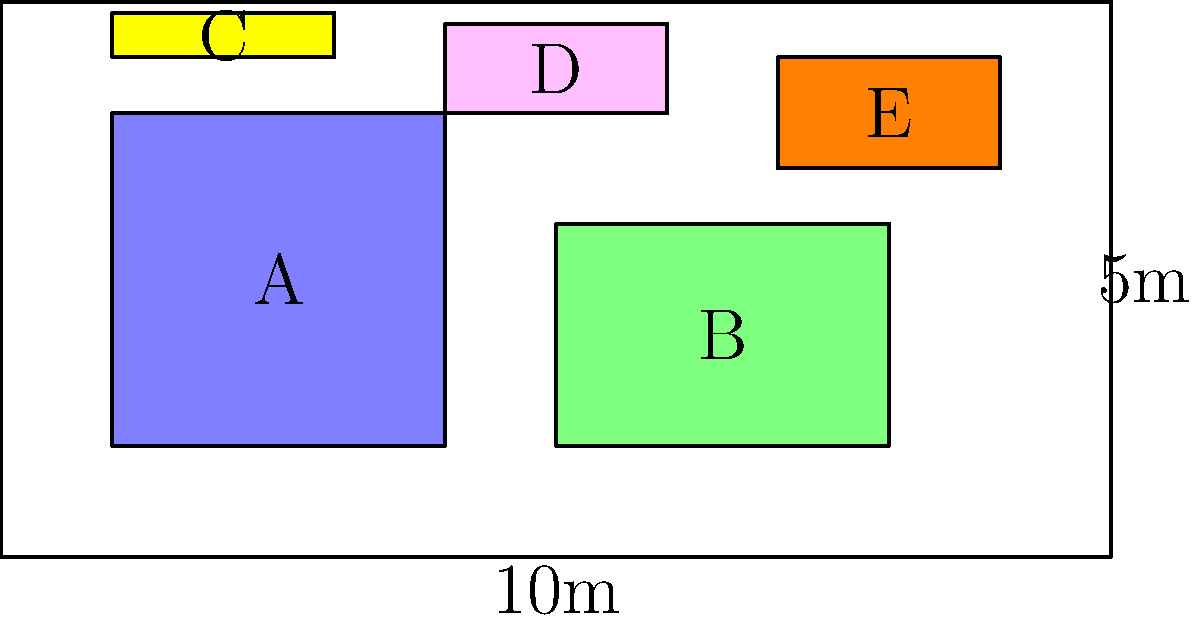As a logistics specialist for aerospace industries, you need to optimize the arrangement of shipping containers on a cargo plane. The cargo floor measures 10m x 5m. Given the following container dimensions:

A: 3m x 3m
B: 3m x 2m
C: 2m x 0.4m
D: 2m x 0.8m
E: 2m x 1m

What is the maximum number of additional containers of size 1m x 1m that can be placed on the remaining floor space without overlapping or exceeding the cargo floor dimensions? To solve this problem, we'll follow these steps:

1. Calculate the total area of the cargo floor:
   $A_{total} = 10m \times 5m = 50m^2$

2. Calculate the area occupied by each container:
   A: $3m \times 3m = 9m^2$
   B: $3m \times 2m = 6m^2$
   C: $2m \times 0.4m = 0.8m^2$
   D: $2m \times 0.8m = 1.6m^2$
   E: $2m \times 1m = 2m^2$

3. Sum up the total area occupied by existing containers:
   $A_{occupied} = 9 + 6 + 0.8 + 1.6 + 2 = 19.4m^2$

4. Calculate the remaining area:
   $A_{remaining} = A_{total} - A_{occupied} = 50m^2 - 19.4m^2 = 30.6m^2$

5. Determine the number of 1m x 1m containers that can fit in the remaining area:
   $N = \lfloor A_{remaining} \div (1m \times 1m) \rfloor = \lfloor 30.6 \rfloor = 30$

However, we need to consider the actual layout constraints. The remaining space is not a perfect rectangle, and we must account for the gaps between existing containers. 

6. Analyze the layout:
   - There's a 2m x 1m space between containers A and B
   - A 1m x 5m strip along the left edge
   - A 1m x 5m strip along the right edge
   - Various smaller spaces that can accommodate 1m x 1m containers

7. Count the actual number of 1m x 1m containers that can fit:
   - 2 between A and B
   - 5 along the left edge
   - 5 along the right edge
   - 4 in the top-left corner
   - 3 in the top-right corner
   - 4 in various smaller spaces

8. Sum up the total number of additional 1m x 1m containers:
   $2 + 5 + 5 + 4 + 3 + 4 = 23$

Therefore, the maximum number of additional 1m x 1m containers that can be placed is 23.
Answer: 23 containers 